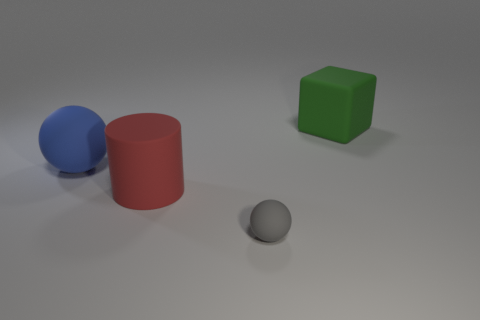Add 3 green things. How many objects exist? 7 Subtract all cylinders. How many objects are left? 3 Subtract all red things. Subtract all brown shiny blocks. How many objects are left? 3 Add 2 big blue things. How many big blue things are left? 3 Add 4 gray spheres. How many gray spheres exist? 5 Subtract 0 cyan balls. How many objects are left? 4 